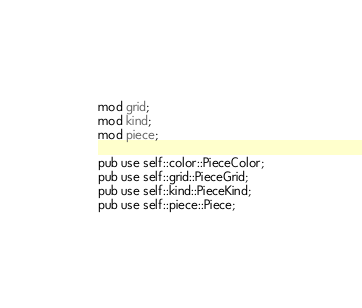<code> <loc_0><loc_0><loc_500><loc_500><_Rust_>mod grid;
mod kind;
mod piece;

pub use self::color::PieceColor;
pub use self::grid::PieceGrid;
pub use self::kind::PieceKind;
pub use self::piece::Piece;
</code> 